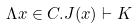<formula> <loc_0><loc_0><loc_500><loc_500>\Lambda x \in C . J ( x ) \vdash K</formula> 